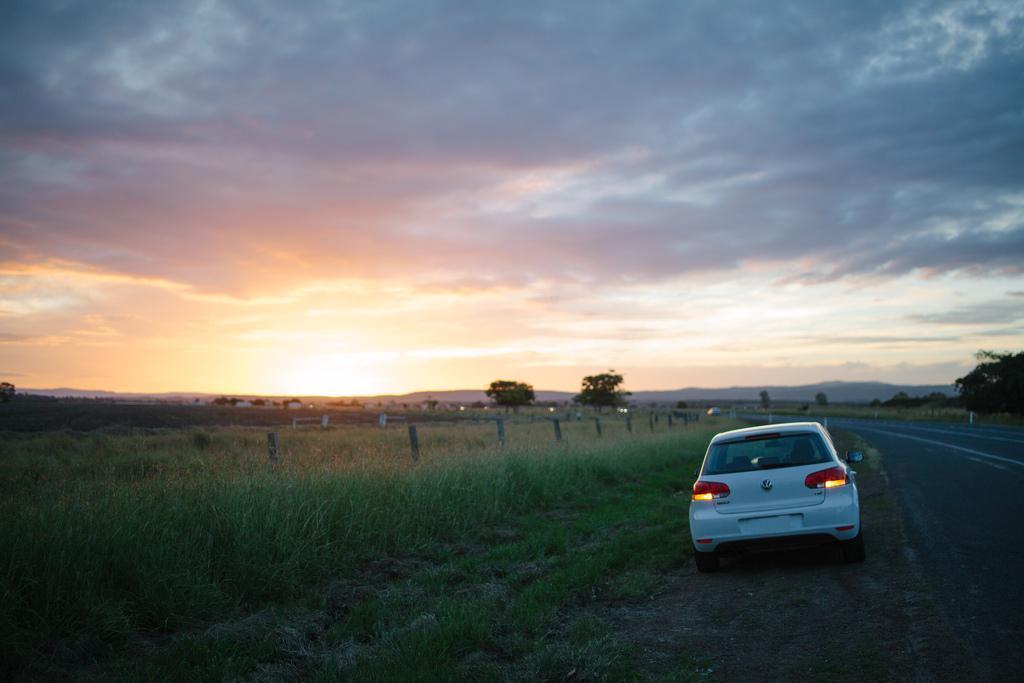Please provide a concise description of this image. In this image there is a white car beside the road in the lift side there is a grass and fencing, there are trees in the land in the background there is cloudy sky with sunset. 